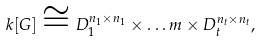Convert formula to latex. <formula><loc_0><loc_0><loc_500><loc_500>k [ G ] \cong D _ { 1 } ^ { n _ { 1 } \times n _ { 1 } } \times \dots m \times D _ { t } ^ { n _ { t } \times n _ { t } } ,</formula> 